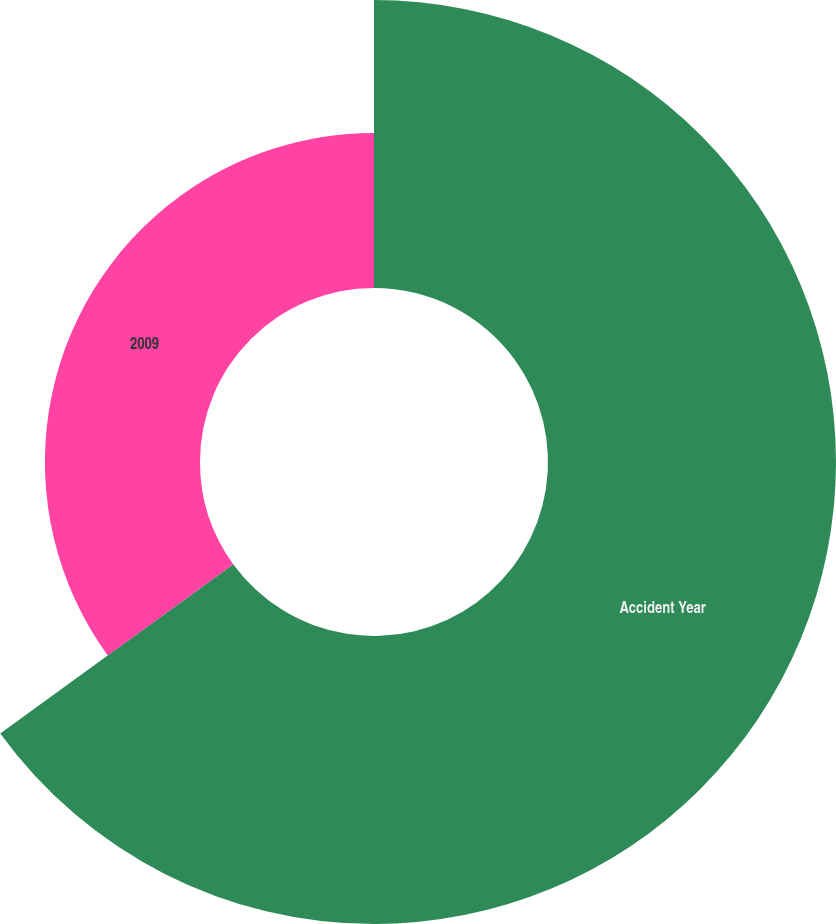Convert chart. <chart><loc_0><loc_0><loc_500><loc_500><pie_chart><fcel>Accident Year<fcel>2009<nl><fcel>65.0%<fcel>35.0%<nl></chart> 